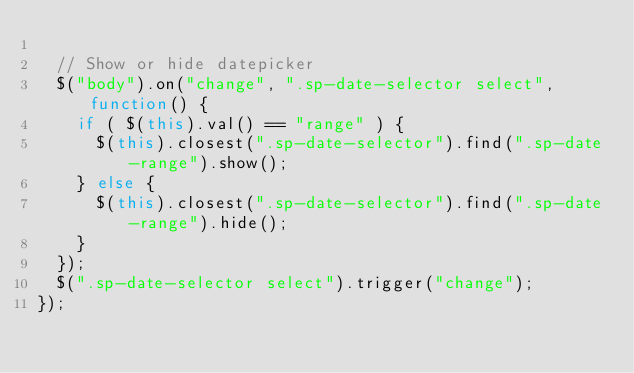Convert code to text. <code><loc_0><loc_0><loc_500><loc_500><_JavaScript_>
	// Show or hide datepicker
	$("body").on("change", ".sp-date-selector select", function() {
		if ( $(this).val() == "range" ) {
			$(this).closest(".sp-date-selector").find(".sp-date-range").show();
		} else {
			$(this).closest(".sp-date-selector").find(".sp-date-range").hide();
		}
	});
	$(".sp-date-selector select").trigger("change");
});</code> 